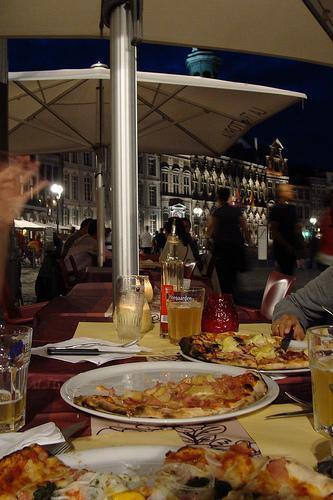How many poles are in this picture?
Give a very brief answer. 2. 